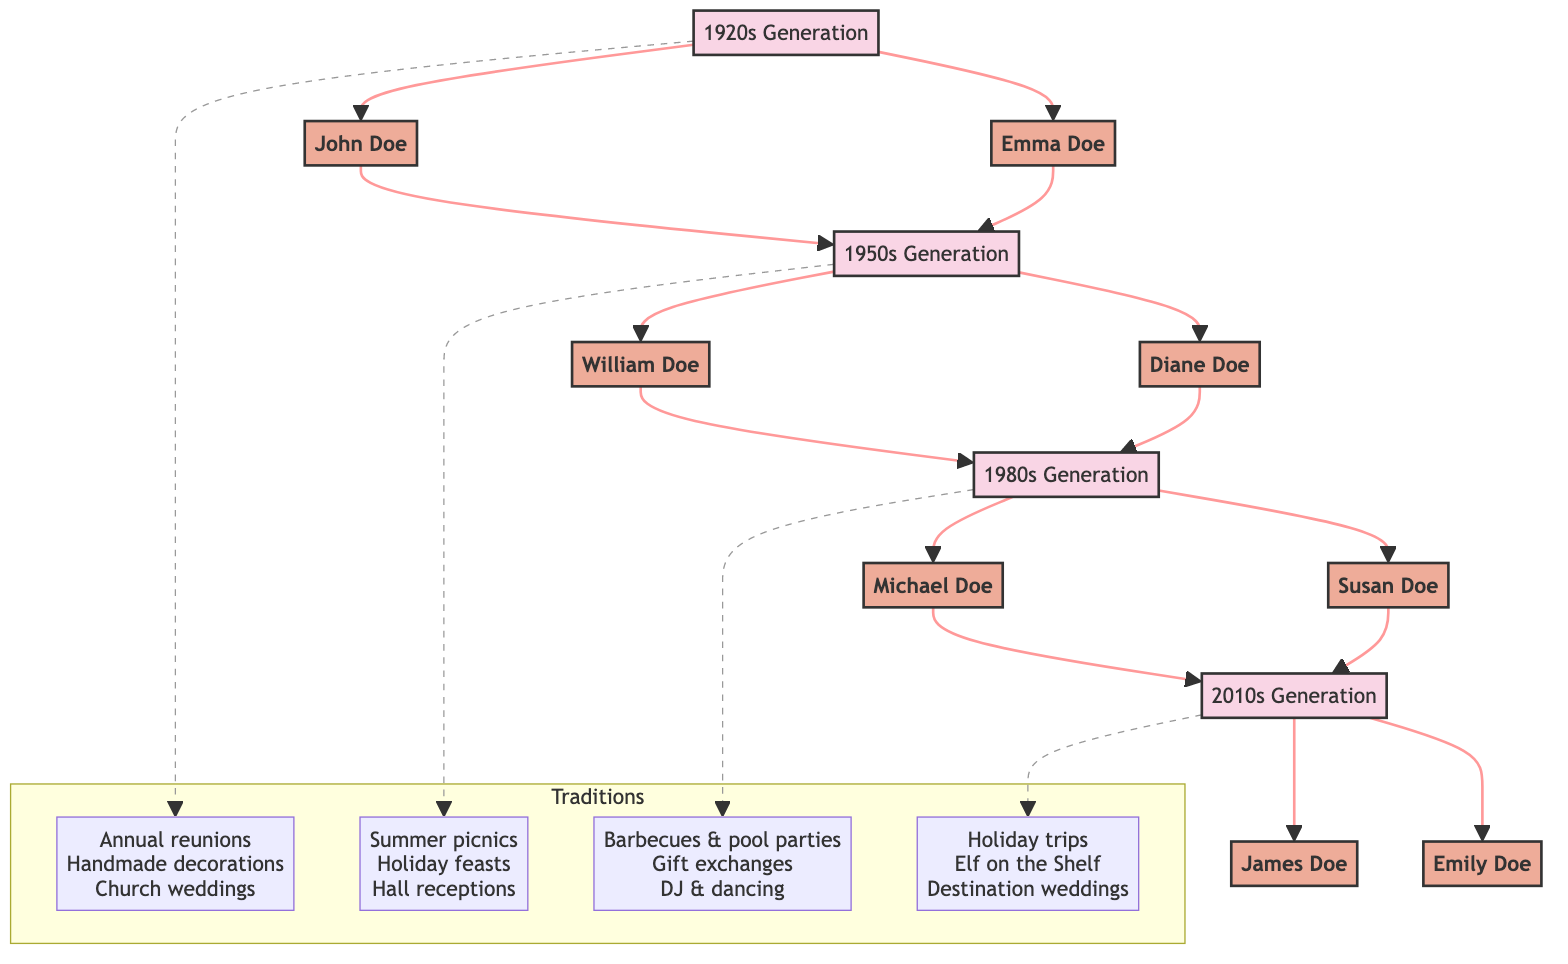What is the main gathering tradition in the 1950s? In the diagram, the 1950s generation's family gathering tradition is listed as "Summer picnics at the local park," which appears directly associated with the 1950s node.
Answer: Summer picnics at the local park How many key members are there in the 1980s generation? Referring to the diagram, the 1980s generation includes two key members: "Michael Doe" and "Susan Doe." Hence, the count is determined by identifying the nodes associated with the 1980s generation.
Answer: 2 Which generation had weddings held in rented halls? The diagram clearly links the tradition of weddings held in rented halls to the 1950s generation, as indicated in the traditions list for that time period.
Answer: 1950s What is the unique wedding trend in the 2010s? By examining the diagram, the 2010s generation features "Destination weddings and themed events" as their wedding tradition, marking a distinct event choice highlighted alongside the key members of that era.
Answer: Destination weddings and themed events Who are the key members of the 1920s generation? The diagram identifies two key members from the 1920s generation, specifically showing their connections as "John Doe" and "Emma Doe." This information can be easily read from the related nodes highlighting their relationship.
Answer: John Doe, Emma Doe What gathering tradition evolved into holiday trips in the 2010s? To find this, we note that the 2010s generation replaced prior traditions with "Holiday trips to various destinations," indicating a shift from the earlier decades' family gatherings such as picnics and reunions.
Answer: Holiday trips to various destinations Which generation introduced barbecues and pool parties? The diagram shows that the 1980s generation adopted "Barbecues and pool parties" as their family gathering tradition, marking a notable style change associated directly with that period's activities.
Answer: 1980s How are the Christmas celebrations in the 1920s described? According to the diagram, Christmas celebrations during the 1920s are characterized by "Handmade decorations and caroling," directly mentioned in the traditions for that generation.
Answer: Handmade decorations and caroling 